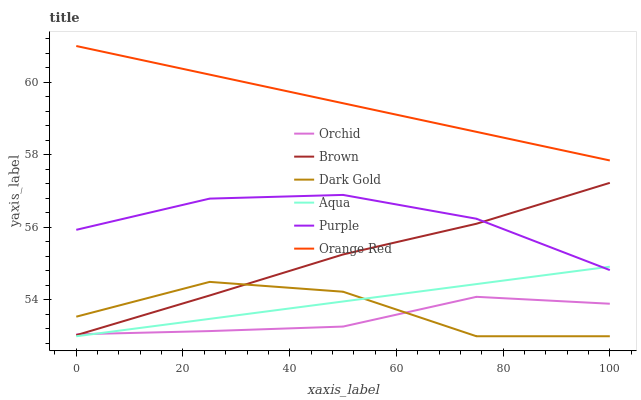Does Orchid have the minimum area under the curve?
Answer yes or no. Yes. Does Orange Red have the maximum area under the curve?
Answer yes or no. Yes. Does Dark Gold have the minimum area under the curve?
Answer yes or no. No. Does Dark Gold have the maximum area under the curve?
Answer yes or no. No. Is Orange Red the smoothest?
Answer yes or no. Yes. Is Dark Gold the roughest?
Answer yes or no. Yes. Is Purple the smoothest?
Answer yes or no. No. Is Purple the roughest?
Answer yes or no. No. Does Dark Gold have the lowest value?
Answer yes or no. Yes. Does Purple have the lowest value?
Answer yes or no. No. Does Orange Red have the highest value?
Answer yes or no. Yes. Does Dark Gold have the highest value?
Answer yes or no. No. Is Purple less than Orange Red?
Answer yes or no. Yes. Is Orange Red greater than Dark Gold?
Answer yes or no. Yes. Does Orchid intersect Brown?
Answer yes or no. Yes. Is Orchid less than Brown?
Answer yes or no. No. Is Orchid greater than Brown?
Answer yes or no. No. Does Purple intersect Orange Red?
Answer yes or no. No. 